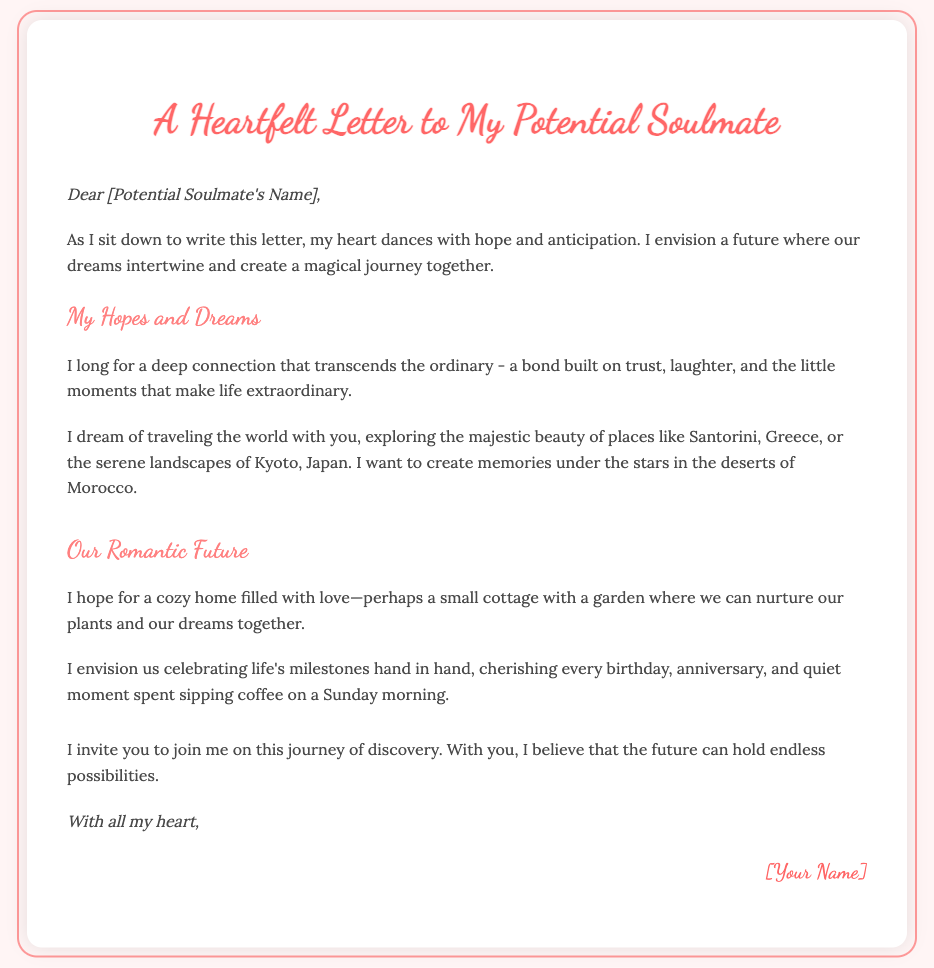What is the title of the letter? The title is prominently displayed at the top of the document, indicating the main theme.
Answer: A Heartfelt Letter to My Potential Soulmate Who is the letter addressed to? The letter begins with a greeting that includes a placeholder for the recipient's name.
Answer: [Potential Soulmate's Name] What locations are mentioned for travel dreams? The document lists two specific locations that the writer dreams of traveling to with their soulmate.
Answer: Santorini, Greece; Kyoto, Japan What type of home does the writer envision? The writer describes a kind of home that embodies their hopes for the future with their soulmate.
Answer: Cozy home What activities does the writer want to share on a Sunday morning? The writer expresses a desire for shared experiences during a specific time of the week.
Answer: Sipping coffee What emotions are associated with the writer's hopes? The letter reflects a strong sense of feeling connected to the recipient based on shared dreams.
Answer: Hope and anticipation What is the closing phrase used in the letter? The closing of the letter wraps up the writer's sentiments, emphasizing the emotion behind it.
Answer: With all my heart What is the overall theme of the letter? The letter communicates a specific overarching idea that combines aspirations and romantic desires.
Answer: Hope for a romantic future 